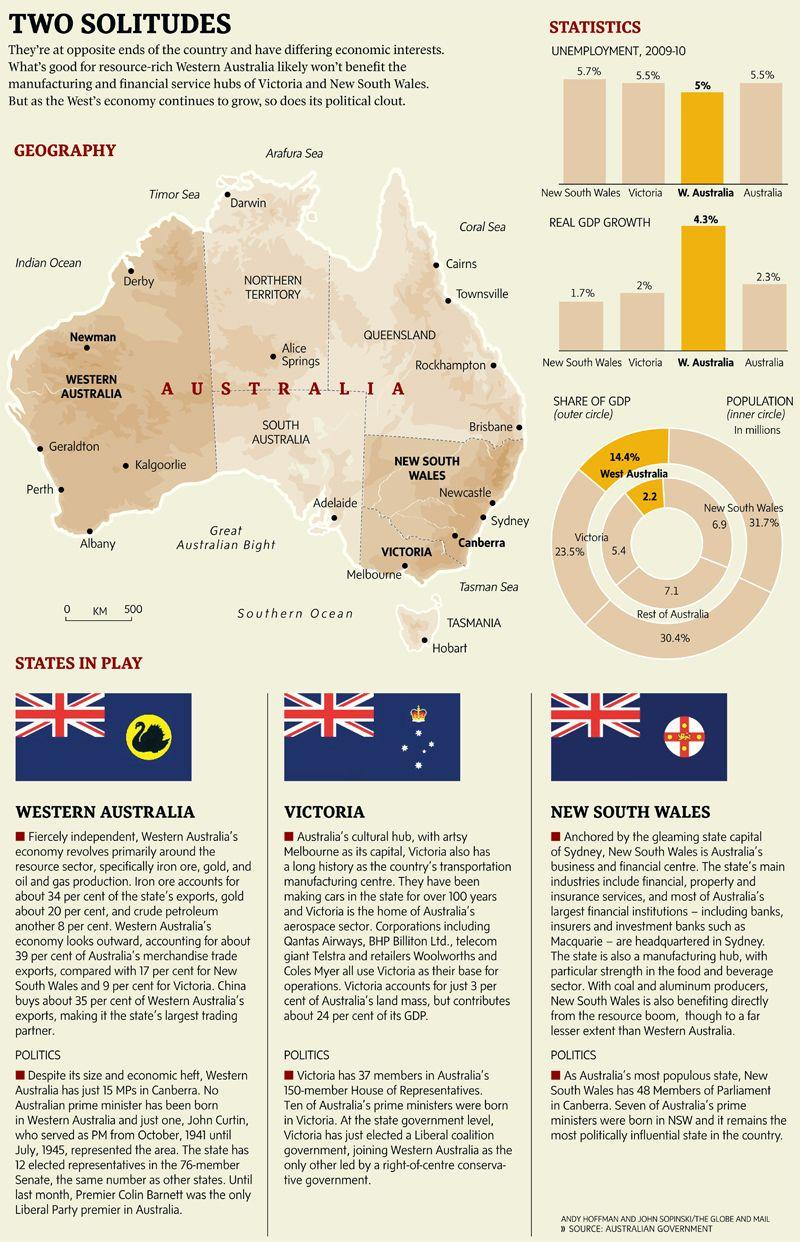Outline some significant characteristics in this image. Australia's cultural hub is Victoria. According to data from New South Wales and Victoria in 2009-10, the combined total percentage of unemployment was 11.2%. New South Wales is the most politically influential state in the country. According to statistics, Australia has experienced the second highest real GDP growth among all states. 